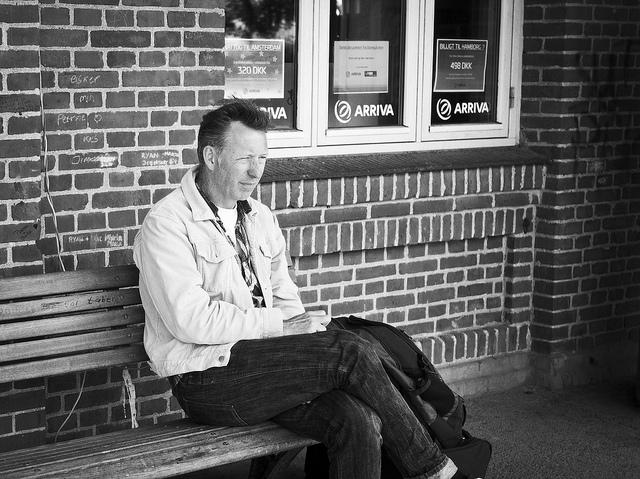What is running down the side of the building on the left side behind the bench?
Quick response, please. Wire. What is the man doing with his two legs?
Keep it brief. Crossing them. Is this in America?
Concise answer only. No. 